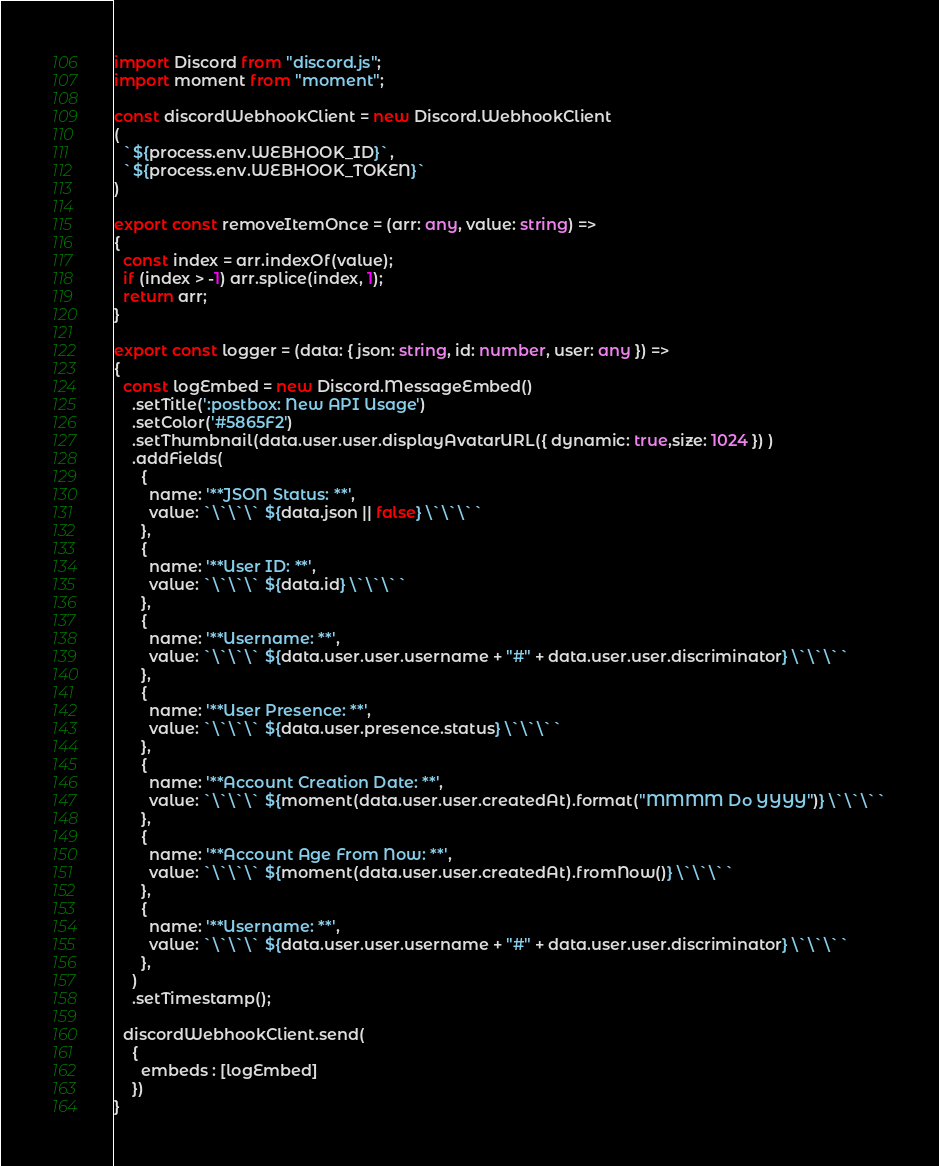<code> <loc_0><loc_0><loc_500><loc_500><_TypeScript_>import Discord from "discord.js";
import moment from "moment";

const discordWebhookClient = new Discord.WebhookClient
(
  `${process.env.WEBHOOK_ID}`,
  `${process.env.WEBHOOK_TOKEN}`
)

export const removeItemOnce = (arr: any, value: string) =>
{
  const index = arr.indexOf(value);
  if (index > -1) arr.splice(index, 1);
  return arr;
}

export const logger = (data: { json: string, id: number, user: any }) =>
{
  const logEmbed = new Discord.MessageEmbed()
    .setTitle(':postbox: New API Usage')
    .setColor('#5865F2')
    .setThumbnail(data.user.user.displayAvatarURL({ dynamic: true,size: 1024 }) )
    .addFields(
      {
        name: '**JSON Status: **',
        value: `\`\`\` ${data.json || false} \`\`\``
      },
      {
        name: '**User ID: **',
        value: `\`\`\` ${data.id} \`\`\``
      },
      {
        name: '**Username: **',
        value: `\`\`\` ${data.user.user.username + "#" + data.user.user.discriminator} \`\`\``
      },
      {
        name: '**User Presence: **',
        value: `\`\`\` ${data.user.presence.status} \`\`\``
      },
      {
        name: '**Account Creation Date: **',
        value: `\`\`\` ${moment(data.user.user.createdAt).format("MMMM Do YYYY")} \`\`\``
      },
      {
        name: '**Account Age From Now: **',
        value: `\`\`\` ${moment(data.user.user.createdAt).fromNow()} \`\`\``
      },
      {
        name: '**Username: **',
        value: `\`\`\` ${data.user.user.username + "#" + data.user.user.discriminator} \`\`\``
      },
    )
    .setTimestamp();

  discordWebhookClient.send(
    {
      embeds : [logEmbed]
    })
}
</code> 